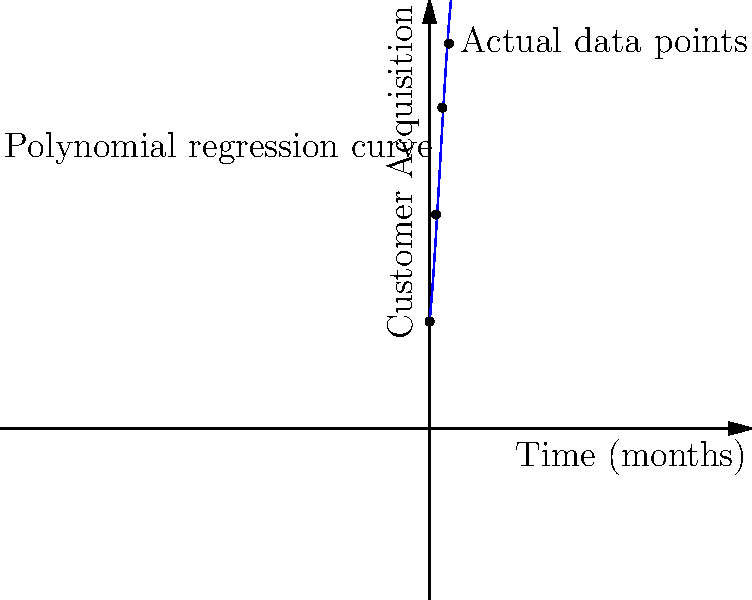As a product manager, you've been tasked with forecasting customer acquisition rates for the next year. You've collected data for the past 9 months and plotted it on a graph. You've also fitted a third-degree polynomial regression curve to the data. Based on the graph, what is the approximate number of new customers you expect to acquire in the 12th month, and what potential concern should you raise to your manager about this forecast? To answer this question, we need to analyze the graph and understand the implications of the polynomial regression curve:

1. The blue curve represents the third-degree polynomial regression fitted to the actual data points (shown as dots).

2. The x-axis represents time in months, while the y-axis represents the number of customers acquired.

3. To estimate the number of new customers in the 12th month, we need to extend the curve to x = 12 and read the corresponding y-value.

4. Extending the curve visually, we can estimate that at x = 12, the y-value is approximately 190-200 new customers.

5. However, there's a crucial concern to raise: The polynomial curve shows a clear downward trend after the 9-month mark. This suggests that the model predicts a slowdown in customer acquisition rate.

6. This downward trend might not reflect reality, as it's based on extrapolation beyond the available data. In real business scenarios, customer acquisition often doesn't follow such a neat polynomial curve.

7. As a product manager delivering measurable business outcomes, it's important to highlight this potential inaccuracy in the forecast and suggest alternative forecasting methods or gathering more data before making long-term predictions.
Answer: Approximately 190-200 new customers; concern about the predicted slowdown in acquisition rate due to polynomial extrapolation. 